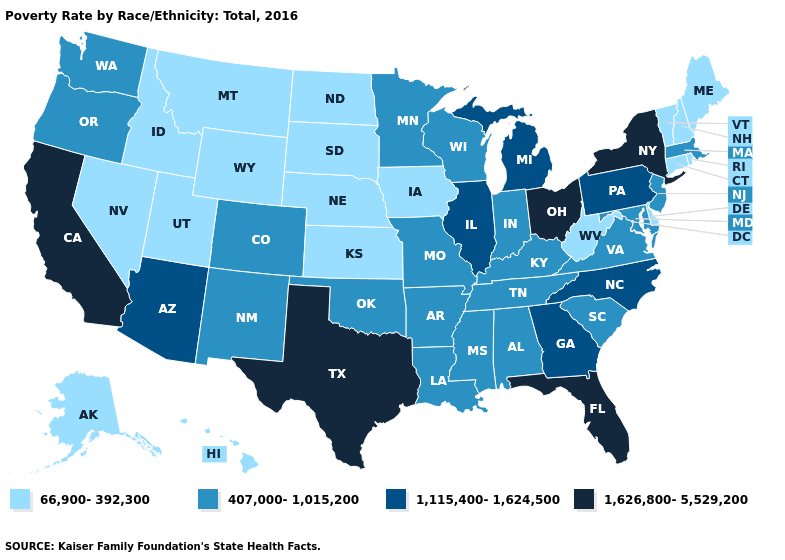What is the highest value in the South ?
Answer briefly. 1,626,800-5,529,200. Does Utah have a lower value than West Virginia?
Be succinct. No. What is the highest value in states that border New Jersey?
Write a very short answer. 1,626,800-5,529,200. What is the value of Indiana?
Write a very short answer. 407,000-1,015,200. What is the lowest value in the MidWest?
Give a very brief answer. 66,900-392,300. Name the states that have a value in the range 407,000-1,015,200?
Answer briefly. Alabama, Arkansas, Colorado, Indiana, Kentucky, Louisiana, Maryland, Massachusetts, Minnesota, Mississippi, Missouri, New Jersey, New Mexico, Oklahoma, Oregon, South Carolina, Tennessee, Virginia, Washington, Wisconsin. Is the legend a continuous bar?
Quick response, please. No. What is the value of Colorado?
Write a very short answer. 407,000-1,015,200. Name the states that have a value in the range 66,900-392,300?
Quick response, please. Alaska, Connecticut, Delaware, Hawaii, Idaho, Iowa, Kansas, Maine, Montana, Nebraska, Nevada, New Hampshire, North Dakota, Rhode Island, South Dakota, Utah, Vermont, West Virginia, Wyoming. Does Colorado have the lowest value in the USA?
Concise answer only. No. Name the states that have a value in the range 1,626,800-5,529,200?
Keep it brief. California, Florida, New York, Ohio, Texas. Does the first symbol in the legend represent the smallest category?
Give a very brief answer. Yes. Which states have the lowest value in the MidWest?
Answer briefly. Iowa, Kansas, Nebraska, North Dakota, South Dakota. Name the states that have a value in the range 1,115,400-1,624,500?
Write a very short answer. Arizona, Georgia, Illinois, Michigan, North Carolina, Pennsylvania. How many symbols are there in the legend?
Be succinct. 4. 